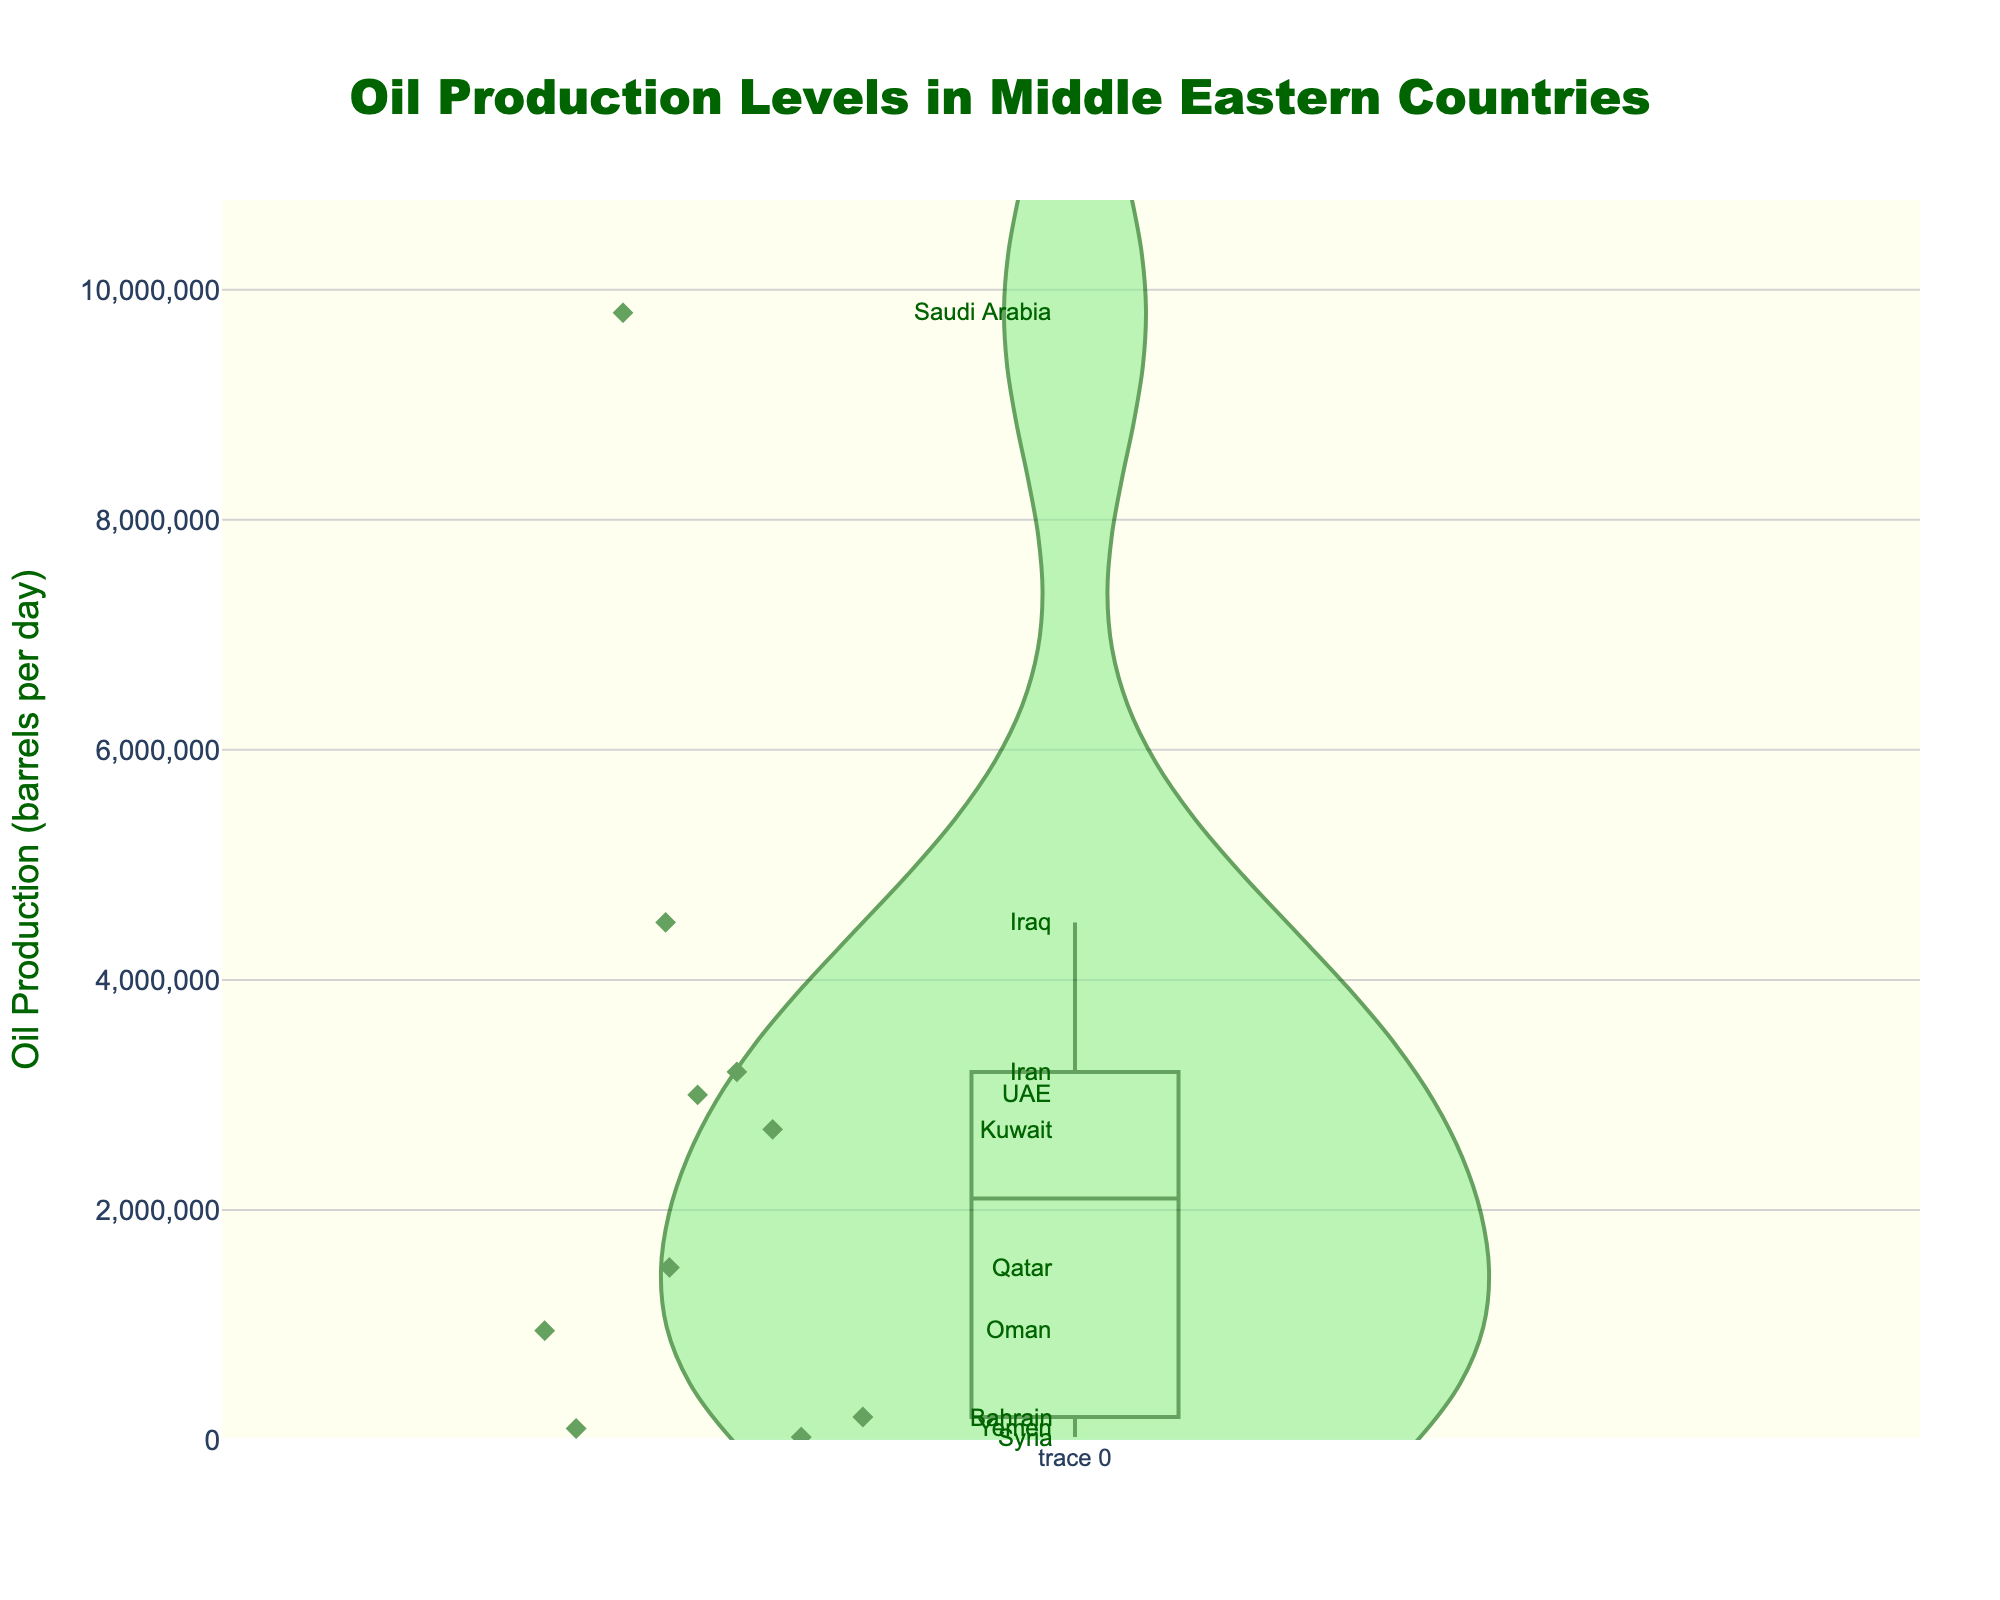What's the title of the figure? The title is displayed at the top center of the figure in a larger font and bold text.
Answer: Oil Production Levels in Middle Eastern Countries What is the highest oil production level shown? The highest oil production level can be determined by locating the data point at the highest vertical position. This point represents the country with the highest daily oil production.
Answer: 9,800,000 barrels per day Which country has the lowest oil production level? To find the country with the lowest oil production, look for the data point closest to the bottom of the vertical axis. The label next to this point will indicate the country.
Answer: Syria How many countries have oil production levels below 3,000,000 barrels per day? Count the number of data points below the 3,000,000 mark on the vertical axis. Each point represents a country.
Answer: 7 Which country produces more oil, Qatar or Oman? Compare the vertical positions of the data points for Qatar and Oman. The country with the higher point produces more oil.
Answer: Qatar What is the median oil production level? To find the median, arrange the production levels in ascending order and identify the middle value. There are 10 data points, so the median is the average of the 5th and 6th values.
Answer: 2,850,000 barrels per day How does Iraq's oil production level compare to Iran's? Identify and compare the data points for Iraq and Iran. The point for Iraq is higher, indicating greater production.
Answer: Iraq produces more List the countries with oil production levels between 2,000,000 and 4,000,000 barrels per day. Identify the data points falling within the vertical range from 2,000,000 to 4,000,000. Label each corresponding country.
Answer: Iran, UAE, Kuwait What is the approximate average oil production of all countries? Sum all oil production values and divide by the number of countries (10). (9.8M + 3.2M + 4.5M + 3M + 2.7M + 1.5M + 950K + 200K + 100K + 25K) / 10
Answer: 2,687,500 barrels per day By how much does Saudi Arabia's production exceed Kuwait's? Subtract Kuwait's production from Saudi Arabia's. (9,800,000 - 2,700,000)
Answer: 7,100,000 barrels per day 